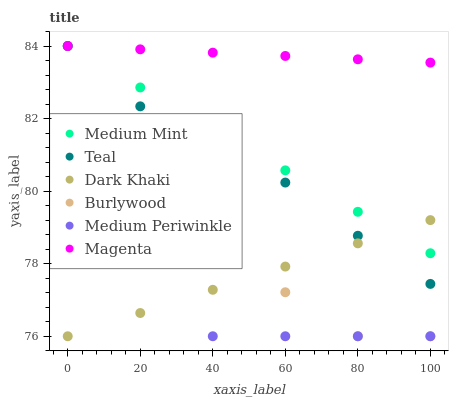Does Medium Periwinkle have the minimum area under the curve?
Answer yes or no. Yes. Does Magenta have the maximum area under the curve?
Answer yes or no. Yes. Does Burlywood have the minimum area under the curve?
Answer yes or no. No. Does Burlywood have the maximum area under the curve?
Answer yes or no. No. Is Medium Mint the smoothest?
Answer yes or no. Yes. Is Burlywood the roughest?
Answer yes or no. Yes. Is Medium Periwinkle the smoothest?
Answer yes or no. No. Is Medium Periwinkle the roughest?
Answer yes or no. No. Does Burlywood have the lowest value?
Answer yes or no. Yes. Does Teal have the lowest value?
Answer yes or no. No. Does Magenta have the highest value?
Answer yes or no. Yes. Does Burlywood have the highest value?
Answer yes or no. No. Is Burlywood less than Teal?
Answer yes or no. Yes. Is Magenta greater than Burlywood?
Answer yes or no. Yes. Does Medium Mint intersect Teal?
Answer yes or no. Yes. Is Medium Mint less than Teal?
Answer yes or no. No. Is Medium Mint greater than Teal?
Answer yes or no. No. Does Burlywood intersect Teal?
Answer yes or no. No. 